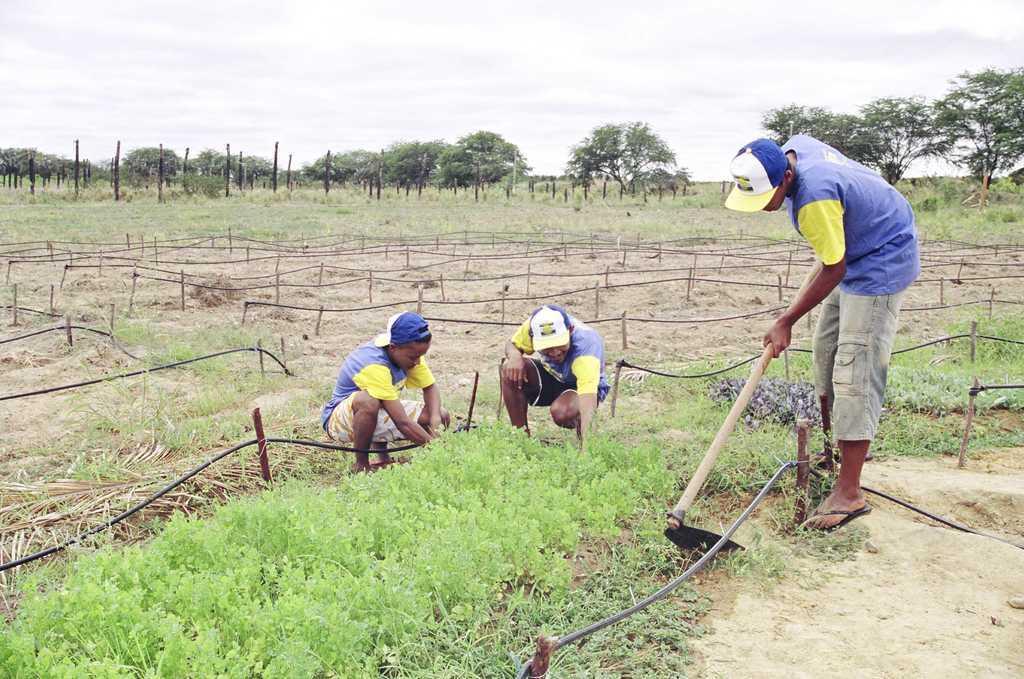In one or two sentences, can you explain what this image depicts? In this image we can see three persons, one of them is holding an object, there are sticks, pipes, there are plants, grass, trees, also we can see the poles, and the sky. 